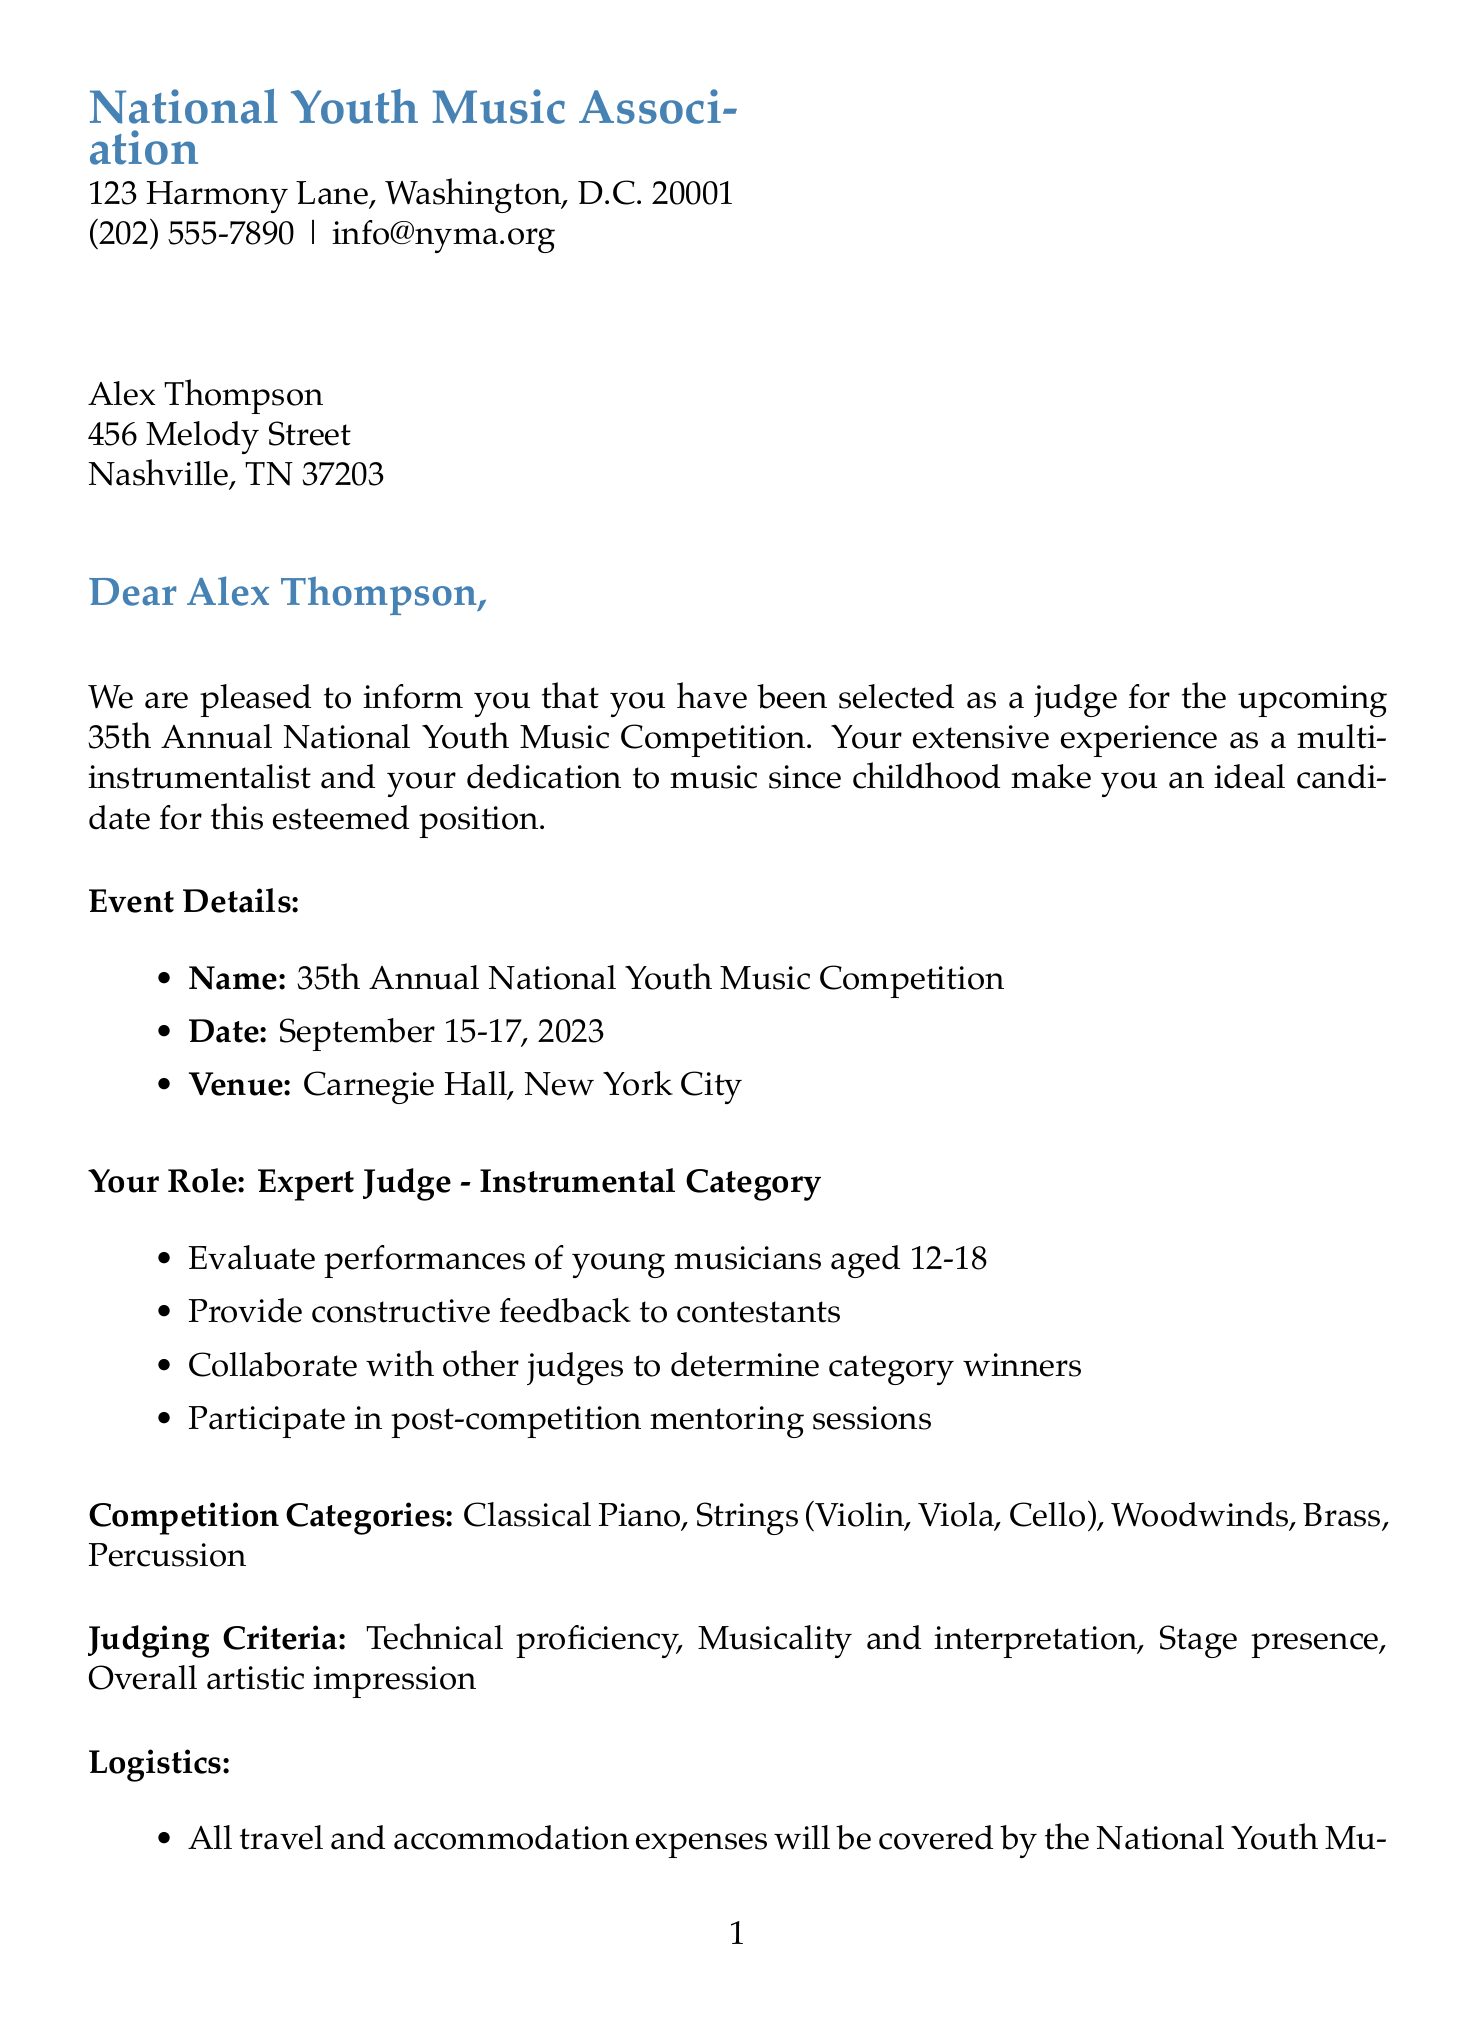What is the name of the organization? The organization that sent the letter is the National Youth Music Association, which is mentioned at the top of the document.
Answer: National Youth Music Association What is the event date? The event date is clearly stated in the document under "Event Details" section as September 15-17, 2023.
Answer: September 15-17, 2023 Who is the contact person for the competition? The contact person for the competition is listed in the additional information section, providing their name and title.
Answer: Emily Chen What is the honorarium amount for participation? The honorarium is specified in the logistics section as an amount paid for participation in the event.
Answer: $2,500 What is required attire for judging sessions? The document mentions requirements regarding the dress code specifically for judging sessions.
Answer: Formal attire How many categories are mentioned for the competition? The document lists the competition categories as a part of its structured information, which can be counted.
Answer: Five What is the per diem amount for meals? The per diem is stated in the logistics section as compensation for meals and incidentals during the event.
Answer: $150 What title does Dr. Michael Rodriguez hold? The title of the person who signed the letter is given at the bottom of the document, specifying their position in the organization.
Answer: Executive Director What role will the recipient have in the competition? The role of the recipient is defined in the document, describing their responsibilities as a judge.
Answer: Expert Judge - Instrumental Category 